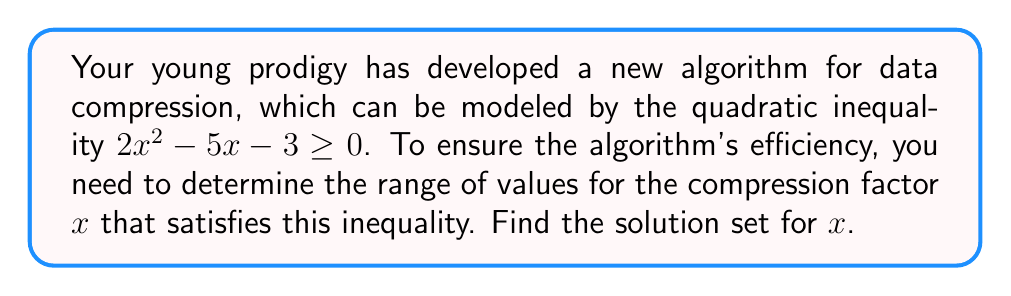Give your solution to this math problem. Let's solve this step-by-step:

1) First, we need to find the roots of the quadratic equation $2x^2 - 5x - 3 = 0$.

2) We can use the quadratic formula: $x = \frac{-b \pm \sqrt{b^2 - 4ac}}{2a}$
   Where $a = 2$, $b = -5$, and $c = -3$

3) Substituting these values:
   $x = \frac{5 \pm \sqrt{(-5)^2 - 4(2)(-3)}}{2(2)}$
   $= \frac{5 \pm \sqrt{25 + 24}}{4}$
   $= \frac{5 \pm \sqrt{49}}{4}$
   $= \frac{5 \pm 7}{4}$

4) This gives us two roots:
   $x_1 = \frac{5 + 7}{4} = 3$
   $x_2 = \frac{5 - 7}{4} = -\frac{1}{2}$

5) Now, we need to determine where the parabola is above or on the x-axis.

6) Since the coefficient of $x^2$ is positive (2), the parabola opens upward.

7) Therefore, the inequality $2x^2 - 5x - 3 \geq 0$ is satisfied when $x \leq -\frac{1}{2}$ or $x \geq 3$.

8) We can write this in interval notation as $(-\infty, -\frac{1}{2}] \cup [3, \infty)$.
Answer: $(-\infty, -\frac{1}{2}] \cup [3, \infty)$ 